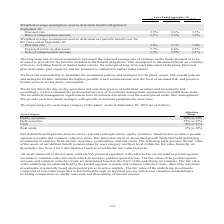According to Cubic's financial document, What does the long-term rate of return assumption represent? the expected average rate of earnings on the funds invested or to be invested to provide for the benefits included in the benefit obligations. The document states: "he long-term rate of return assumption represents the expected average rate of earnings on the funds invested or to be invested to provide for the ben..." Also, How is the long-term rate of return assumption determined? based on a number of factors, including historical market index returns, the anticipated long-term asset allocation of the plans, historical plan return data, plan expenses, and the potential to outperform market index returns. The document states: "enefit obligations. That assumption is determined based on a number of factors, including historical market index returns, the anticipated long-term a..." Also, What are the components under the Weighted-average assumptions used to determine benefit obligation at September 30? The document shows two values: Discount rate and Rate of compensation increase. From the document: "Rate of compensation increase 3.1% 3.3% 3.2% Weighted-average assumptions used to determine net periodic benefit cost for the yea to determine benefit..." Additionally, For the weighted-average assumptions used to determine benefit obligation at September 30, which year has the largest rate of compensation increase? According to the financial document, 2018. The relevant text states: "Years Ended September 30, 2019 2018 2017..." Also, can you calculate: For the weighted-average assumptions used to determine benefit obligation at September 30, what is the change in the discount rate in 2019 from 2018? Based on the calculation: 2.5%-3.6%, the result is -1.1 (percentage). This is based on the information: "it obligation at September 30: Discount rate 2.5% 3.6% 3.3% benefit obligation at September 30: Discount rate 2.5% 3.6% 3.3%..." The key data points involved are: 2.5, 3.6. Also, can you calculate: For the weighted-average assumptions used to determine benefit obligation at September 30, what is the average discount rate across 2017, 2018 and 2019? To answer this question, I need to perform calculations using the financial data. The calculation is: (2.5%+3.6%+3.3%)/3, which equals 3.13 (percentage). This is based on the information: "it obligation at September 30: Discount rate 2.5% 3.6% 3.3% ligation at September 30: Discount rate 2.5% 3.6% 3.3% it obligation at September 30: Discount rate 2.5% 3.6% 3.3% benefit obligation at Sep..." The key data points involved are: 2.5, 3.3, 3.6. 